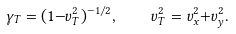Convert formula to latex. <formula><loc_0><loc_0><loc_500><loc_500>\gamma _ { T } = ( 1 { - } v _ { T } ^ { 2 } ) ^ { - 1 / 2 } , \quad v _ { T } ^ { 2 } = v _ { x } ^ { 2 } { + } v _ { y } ^ { 2 } .</formula> 